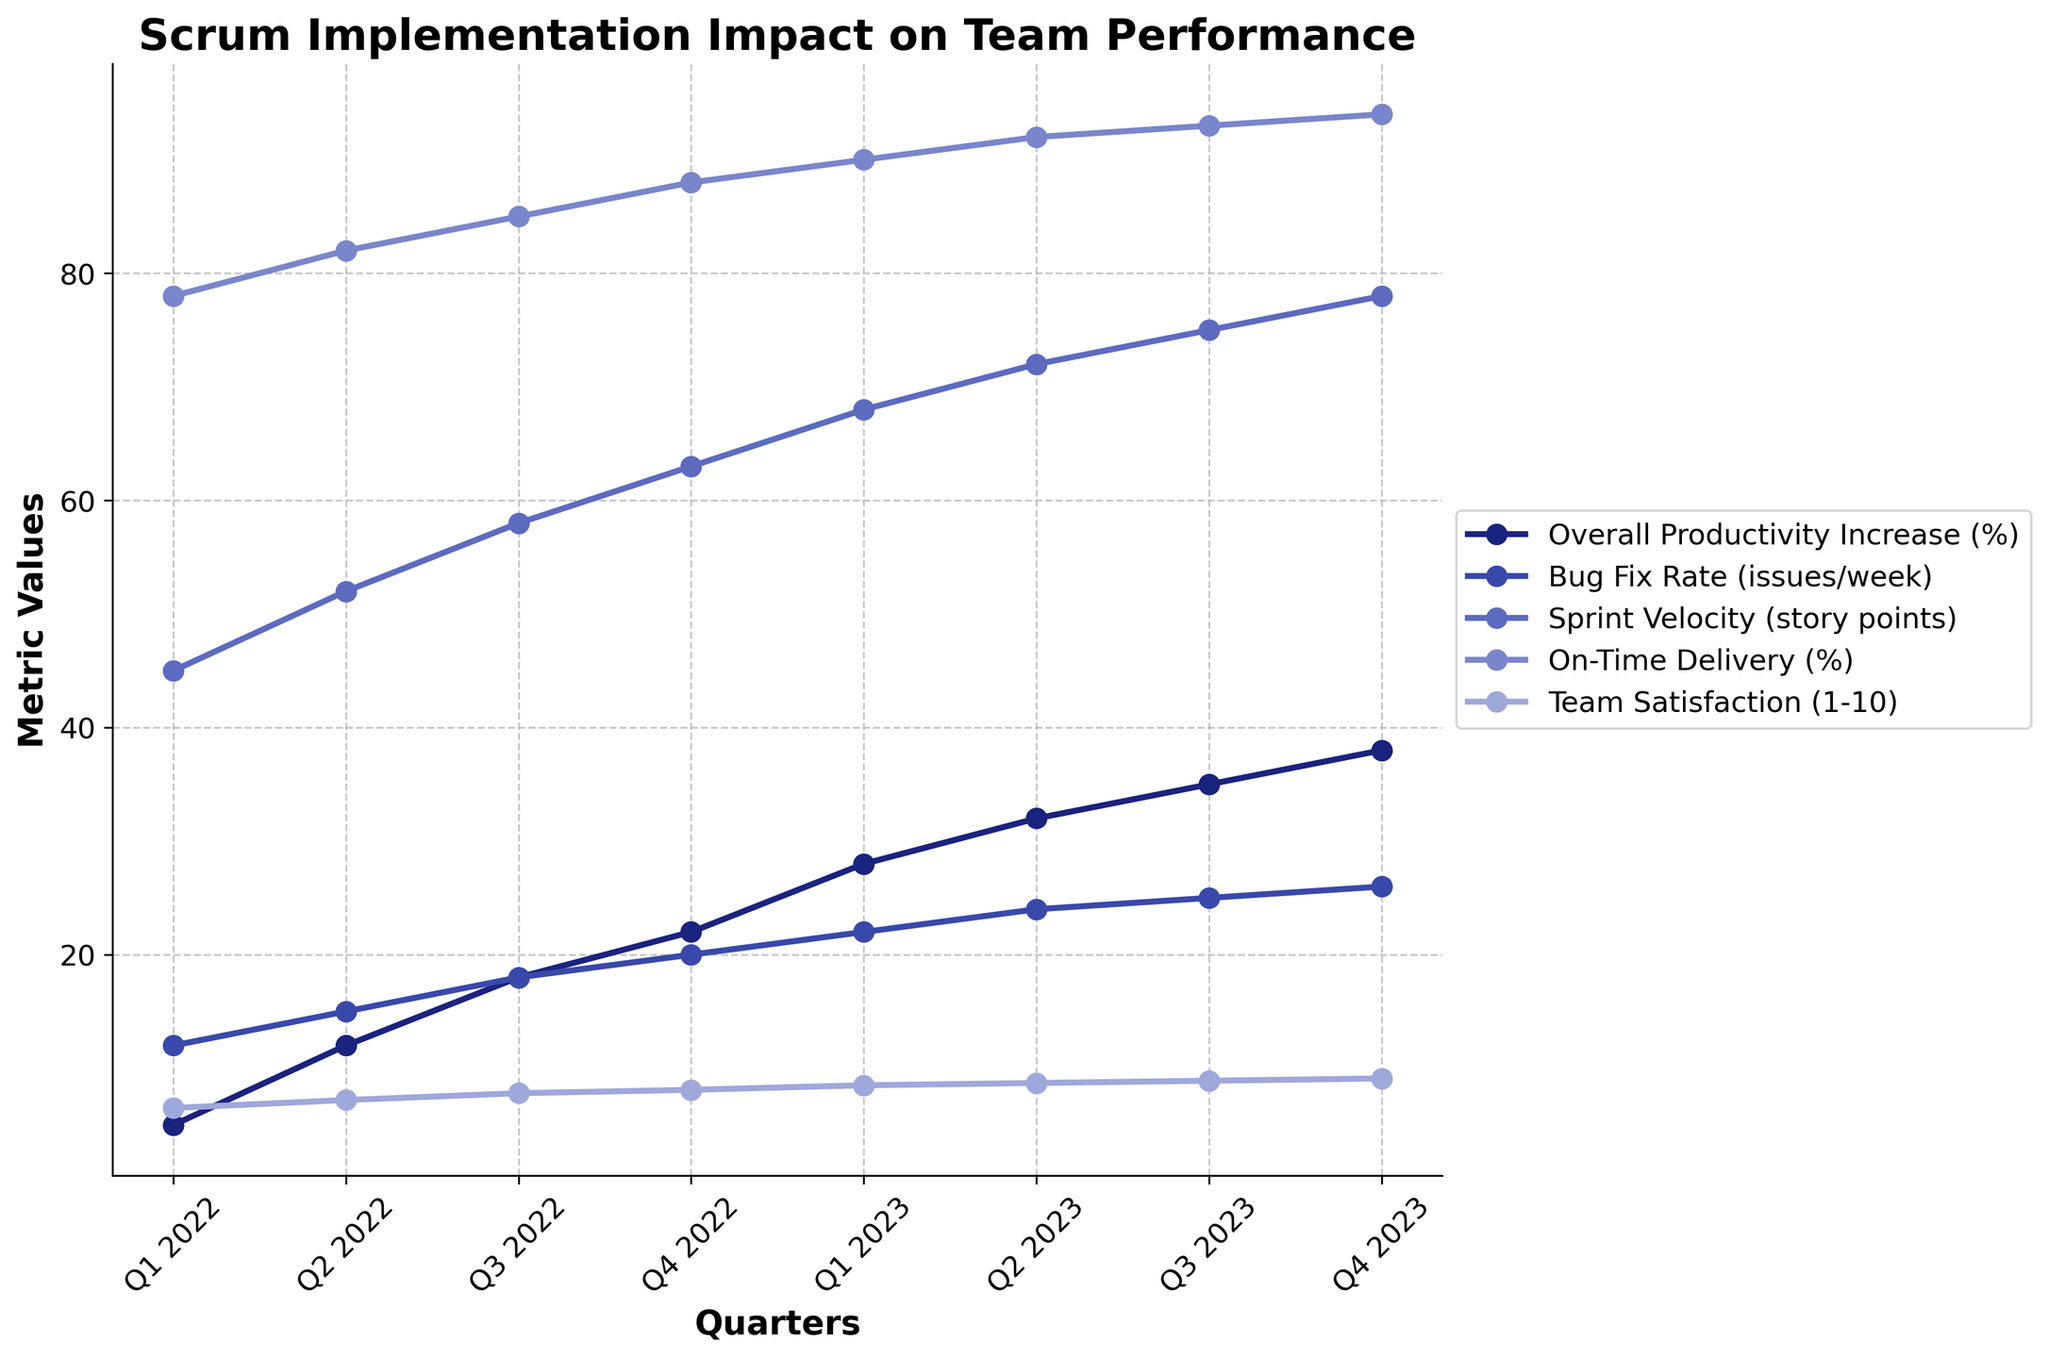which quarter shows the highest increase in team satisfaction? By looking at the line for "Team Satisfaction (1-10)", we observe that Q4 2023 has the highest value of 9.1.
Answer: Q4 2023 which metric had the largest overall improvement from Q1 2022 to Q4 2023? We need to calculate the differences for each metric from Q1 2022 to Q4 2023: Overall Productivity Increase (38% - 5% = 33%), Bug Fix Rate (26 - 12 = 14), Sprint Velocity (78 - 45 = 33), On-Time Delivery (94% - 78% = 16%), and Team Satisfaction (9.1 - 6.5 = 2.6). The largest improvement is observed in Overall Productivity Increase and Sprint Velocity, both with an increase of 33.
Answer: Overall Productivity Increase (%), Sprint Velocity How did Sprint Velocity change from Q1 2022 to Q4 2023? Observing the "Sprint Velocity (story points)" trend, it increased from 45 in Q1 2022 to 78 in Q4 2023. This means an increase of 33 story points.
Answer: Increased by 33 How much did the Bug Fix Rate increase from Q2 2022 to Q3 2022? Looking at the Bug Fix Rate values, it increased from 15 issues/week in Q2 2022 to 18 issues/week in Q3 2022, which is an increase of 3 issues/week.
Answer: 3 issues/week Is there any quarter where all metrics increased compared to the previous quarter? By comparing each quarter to its previous quarter, we find that each metric increased in every quarter, indicating continuous growth across all metrics per quarter.
Answer: Yes In which quarter did the Team Satisfaction first exceed 8? Observing the "Team Satisfaction (1-10)", Team Satisfaction first exceeds 8 in Q4 2022 where it reaches 8.1.
Answer: Q4 2022 Which metric shows the steadiest increase over the observed period? By evaluating the lines, "Overall Productivity Increase (%)" shows a steady, upward trend without any dips.
Answer: Overall Productivity Increase (%) Which quarter had the highest increase in On-Time Delivery compared to the previous quarter? Comparing the On-Time Delivery (%), the highest increase is from Q1 2022 (78%) to Q2 2022 (82%), which is an increase of 4 percentage points.
Answer: Q2 2022 